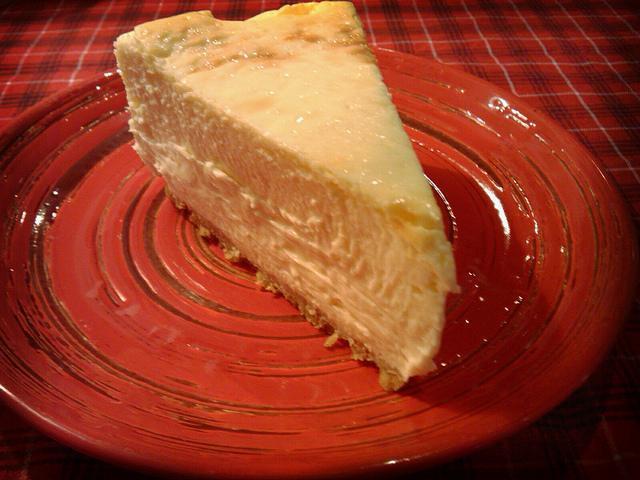How many cakes can you see?
Give a very brief answer. 1. 